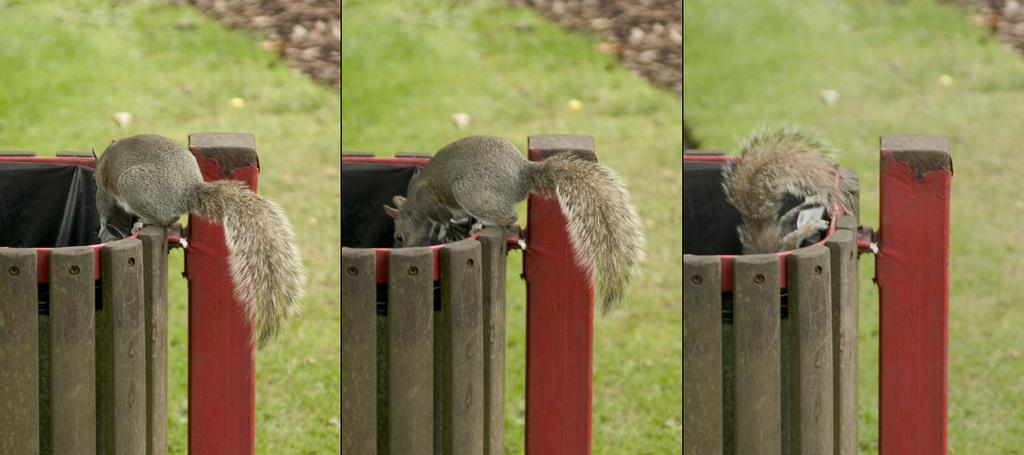What animal is present in the image? There is a squirrel in the image. What is the squirrel standing on? The squirrel is standing on a wooden dustbin. What is the squirrel doing in the image? The squirrel is staring inside the dustbin. What can be seen in the background of the image? There is a grassland in the background of the image. How is the image presented? The image is a photo grid image. What type of humor can be seen in the squirrel's expression in the image? There is no indication of humor in the squirrel's expression in the image; it is simply staring inside the dustbin. What type of oatmeal is the squirrel eating in the image? There is no oatmeal present in the image; the squirrel is standing on a wooden dustbin and staring inside it. 